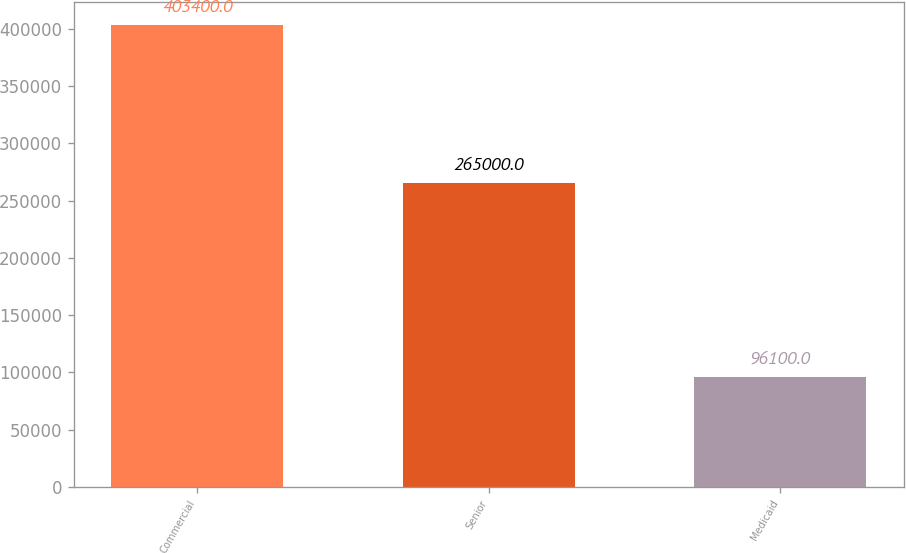Convert chart. <chart><loc_0><loc_0><loc_500><loc_500><bar_chart><fcel>Commercial<fcel>Senior<fcel>Medicaid<nl><fcel>403400<fcel>265000<fcel>96100<nl></chart> 